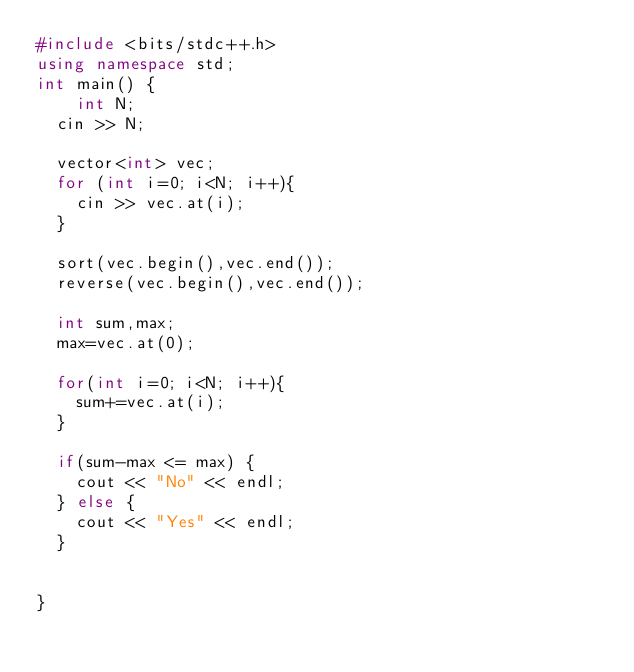<code> <loc_0><loc_0><loc_500><loc_500><_C++_>#include <bits/stdc++.h>
using namespace std;
int main() {
    int N;
  cin >> N;
  
  vector<int> vec;
  for (int i=0; i<N; i++){
    cin >> vec.at(i);
  }
  
  sort(vec.begin(),vec.end());
  reverse(vec.begin(),vec.end());
  
  int sum,max;
  max=vec.at(0);
  
  for(int i=0; i<N; i++){
    sum+=vec.at(i);
  }
  
  if(sum-max <= max) {
    cout << "No" << endl;
  } else {
    cout << "Yes" << endl;
  }
   
  
}</code> 